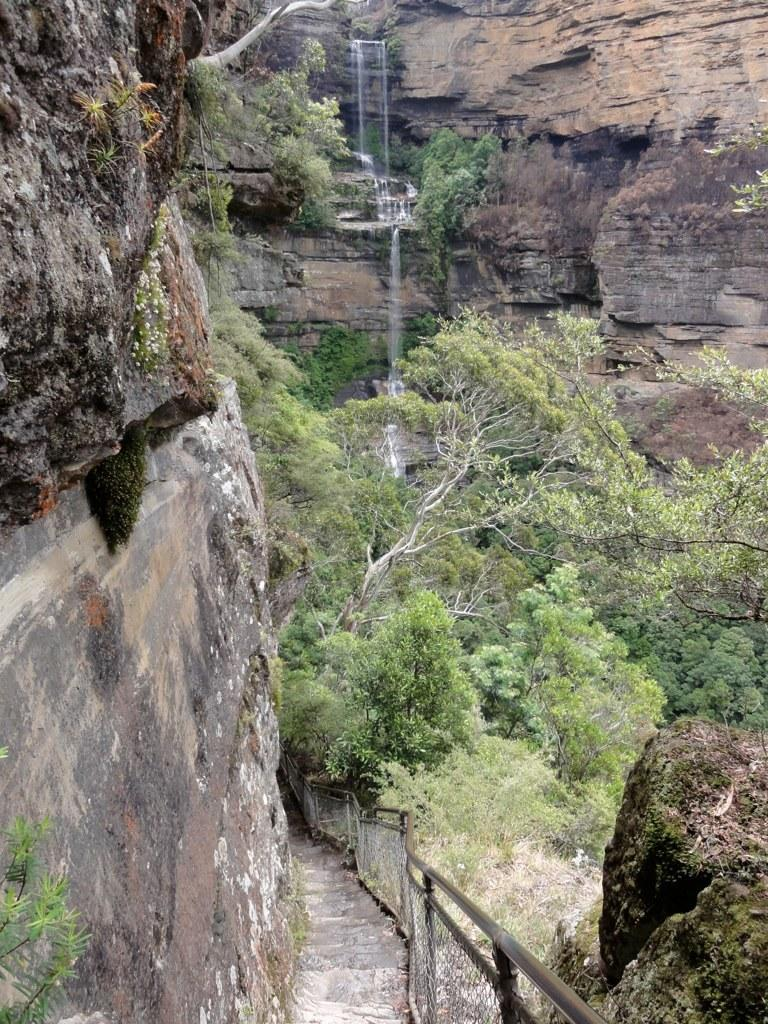What natural feature is the main subject of the image? There is a waterfall in the image. Where is the waterfall situated? The waterfall is located on hills. What type of vegetation can be seen in the image? Trees are present in the image. What is visible at the bottom of the image? There is a pathway and a fence visible at the bottom of the image. How many eggs are being used in the office depicted in the image? There is no office or eggs present in the image; it features a waterfall on hills with trees, a pathway, and a fence. 